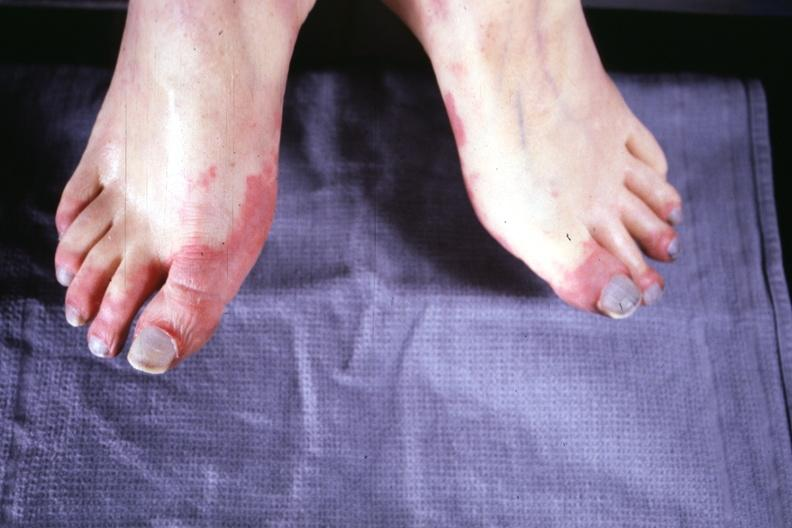what is present?
Answer the question using a single word or phrase. Feet 